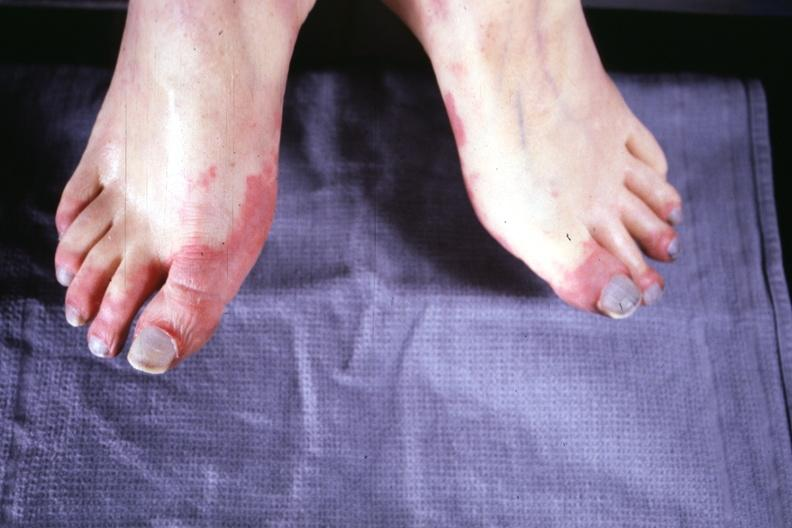what is present?
Answer the question using a single word or phrase. Feet 